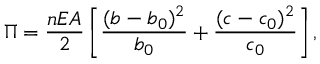<formula> <loc_0><loc_0><loc_500><loc_500>\Pi = \frac { n E A } 2 \left [ \frac { ( b - b _ { 0 } ) ^ { 2 } } { b _ { 0 } } + \frac { ( c - c _ { 0 } ) ^ { 2 } } { c _ { 0 } } \right ] ,</formula> 